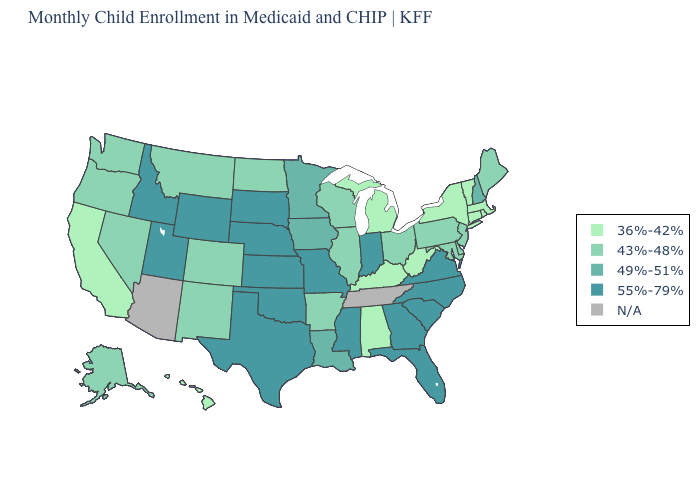Does the map have missing data?
Write a very short answer. Yes. What is the highest value in the MidWest ?
Write a very short answer. 55%-79%. What is the highest value in the USA?
Quick response, please. 55%-79%. What is the value of Florida?
Keep it brief. 55%-79%. What is the lowest value in states that border Kentucky?
Be succinct. 36%-42%. Name the states that have a value in the range 55%-79%?
Write a very short answer. Florida, Georgia, Idaho, Indiana, Kansas, Mississippi, Missouri, Nebraska, North Carolina, Oklahoma, South Carolina, South Dakota, Texas, Utah, Virginia, Wyoming. Does Georgia have the lowest value in the South?
Quick response, please. No. What is the lowest value in the USA?
Be succinct. 36%-42%. Name the states that have a value in the range 49%-51%?
Give a very brief answer. Iowa, Louisiana, Minnesota, New Hampshire. Among the states that border Louisiana , does Arkansas have the lowest value?
Quick response, please. Yes. Name the states that have a value in the range 43%-48%?
Keep it brief. Alaska, Arkansas, Colorado, Delaware, Illinois, Maine, Maryland, Montana, Nevada, New Jersey, New Mexico, North Dakota, Ohio, Oregon, Pennsylvania, Washington, Wisconsin. Name the states that have a value in the range 36%-42%?
Quick response, please. Alabama, California, Connecticut, Hawaii, Kentucky, Massachusetts, Michigan, New York, Rhode Island, Vermont, West Virginia. What is the value of Florida?
Give a very brief answer. 55%-79%. How many symbols are there in the legend?
Write a very short answer. 5. What is the value of Kentucky?
Quick response, please. 36%-42%. 